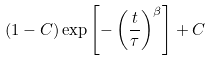Convert formula to latex. <formula><loc_0><loc_0><loc_500><loc_500>( 1 - C ) \exp \left [ - \left ( \frac { t } { \tau } \right ) ^ { \beta } \right ] + C</formula> 